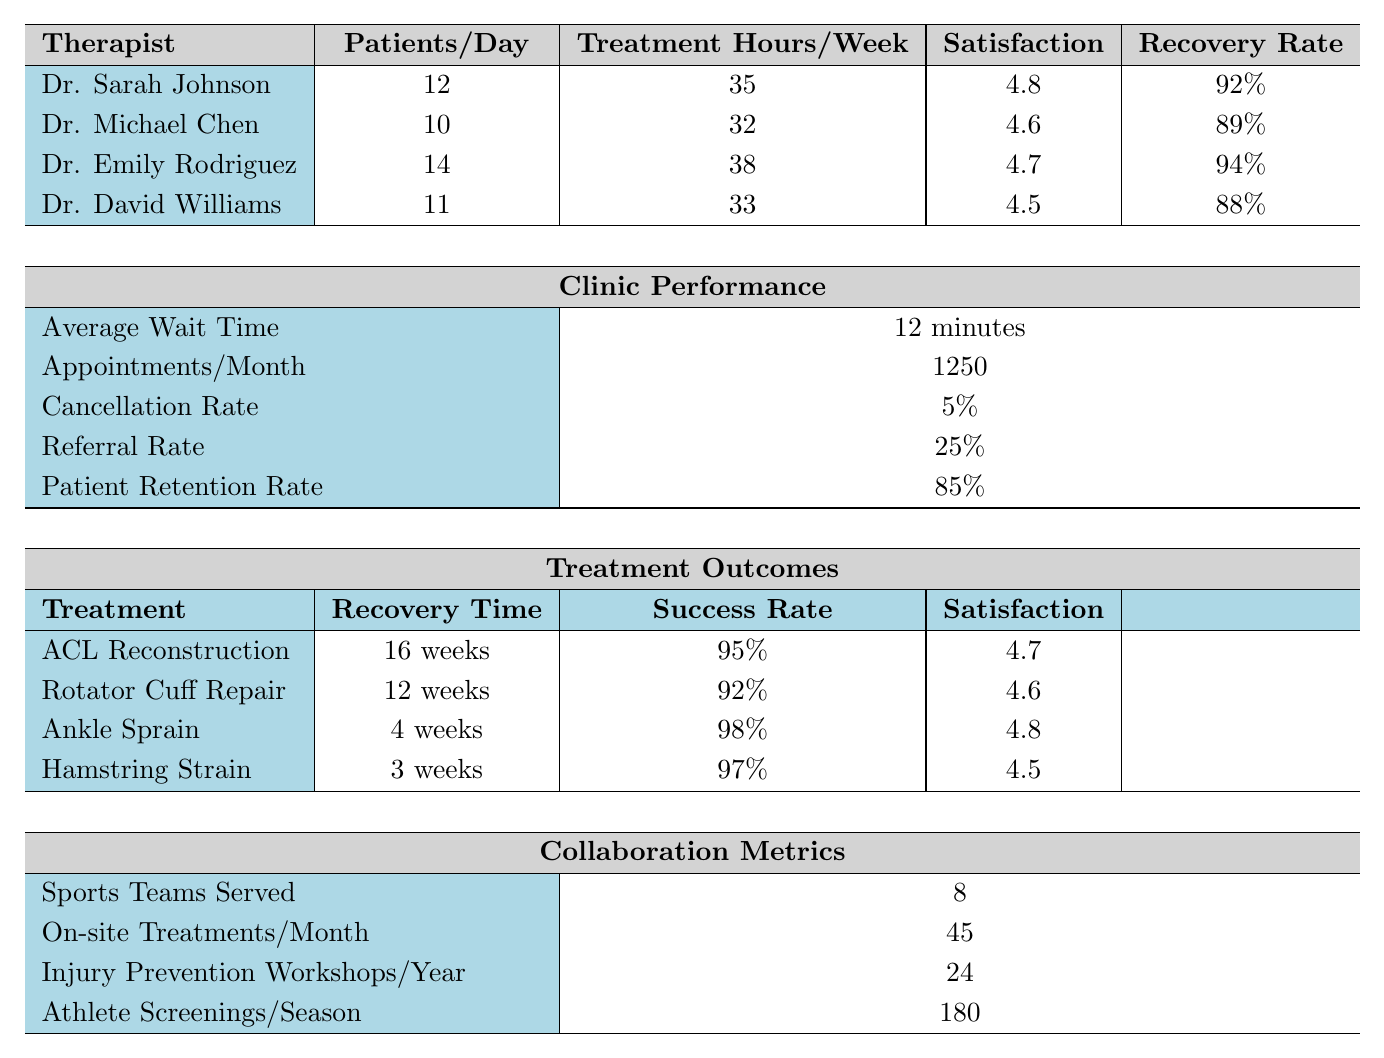What is the highest patient satisfaction score among therapists? By examining the satisfaction scores listed for each therapist (4.8 for Dr. Sarah Johnson, 4.6 for Dr. Michael Chen, 4.7 for Dr. Emily Rodriguez, and 4.5 for Dr. David Williams), we see that Dr. Sarah Johnson has the highest score at 4.8.
Answer: 4.8 How many treatment hours per week does Dr. Emily Rodriguez provide? Directly looking at the relevant row for Dr. Emily Rodriguez, we find that she provides 38 treatment hours per week.
Answer: 38 What is the average recovery rate of all therapists? To find the average recovery rate, we sum the recovery rates (92% + 89% + 94% + 88% = 363%) and divide by the number of therapists (4). Thus, 363% / 4 = 90.75%.
Answer: 90.75% Does Dr. Michael Chen's patients per day exceed Dr. David Williams' patients per day? Dr. Michael Chen sees 10 patients per day, while Dr. David Williams sees 11 patients per day. Therefore, Dr. Michael Chen's patients per day does not exceed Dr. David Williams'.
Answer: No What is the success rate of ACL reconstruction treatment? The table indicates that the success rate for ACL reconstruction is 95%.
Answer: 95% Which therapist has the least years of experience? By comparing the years of experience for each therapist (8 for Dr. Sarah Johnson, 12 for Dr. Michael Chen, 6 for Dr. Emily Rodriguez, and 15 for Dr. David Williams), it is evident that Dr. Emily Rodriguez has the least experience at 6 years.
Answer: Dr. Emily Rodriguez What is the patient retention rate and how does it relate to the cancellation rate? The patient retention rate is 85% and the cancellation rate is 5%. The retention rate is substantially higher than the cancellation rate, suggesting a high level of commitment from patients.
Answer: Higher than cancellation rate How many total patients do Dr. Sarah Johnson and Dr. Emily Rodriguez see in a week combined? Dr. Sarah Johnson sees 12 patients per day and Dr. Emily Rodriguez sees 14 patients per day. Over a typical 5-day workweek, they would see (12 + 14) patients per day * 5 days = 130 patients in total weekly.
Answer: 130 What advantage does Dr. Emily Rodriguez have in terms of patient satisfaction compared to Dr. David Williams? Dr. Emily Rodriguez has a patient satisfaction score of 4.7 while Dr. David Williams has a score of 4.5. This indicates a 0.2 point advantage in terms of patient satisfaction for Dr. Emily Rodriguez over Dr. David Williams.
Answer: 0.2 point advantage How many on-site treatments does the clinic provide per month? According to the table, the clinic provides 45 on-site treatments per month.
Answer: 45 What is the overall average recovery time for the treatments listed? The treatment recovery times are 16 weeks (ACL reconstruction), 12 weeks (rotator cuff repair), 4 weeks (ankle sprain), and 3 weeks (hamstring strain). Therefore, we calculate the average recovery time [(16 + 12 + 4 + 3) / 4 = 35 / 4 = 8.75 weeks].
Answer: 8.75 weeks 